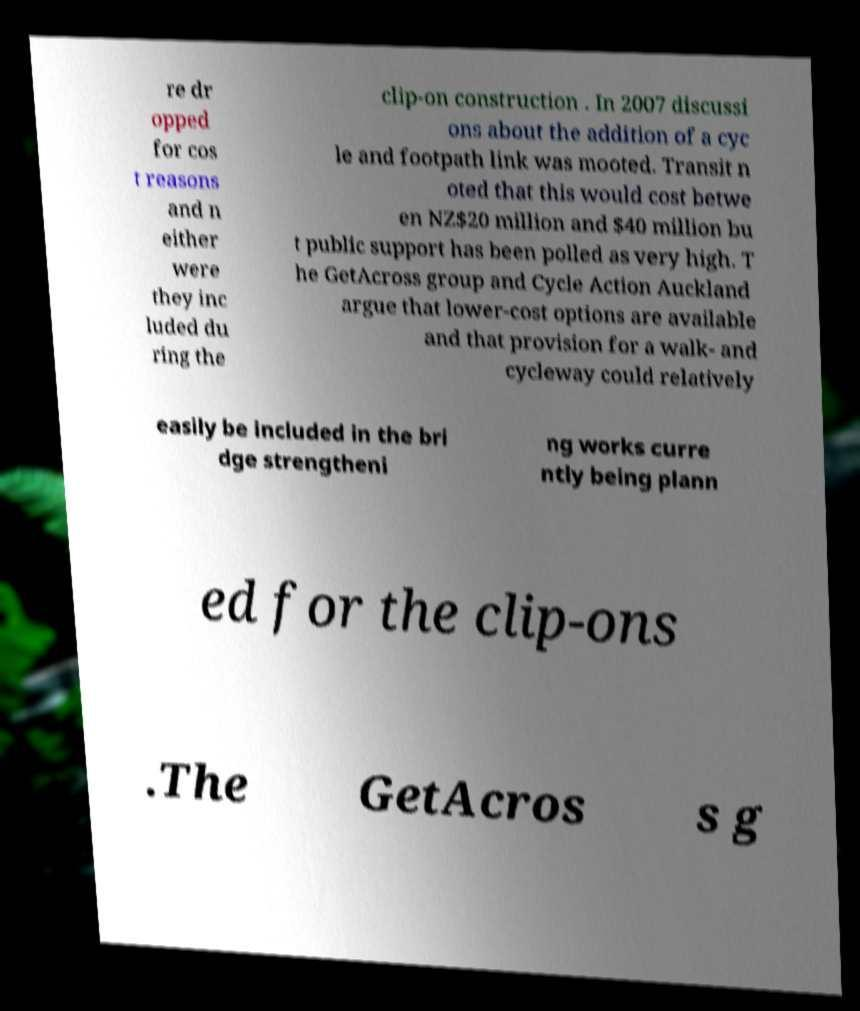Please read and relay the text visible in this image. What does it say? re dr opped for cos t reasons and n either were they inc luded du ring the clip-on construction . In 2007 discussi ons about the addition of a cyc le and footpath link was mooted. Transit n oted that this would cost betwe en NZ$20 million and $40 million bu t public support has been polled as very high. T he GetAcross group and Cycle Action Auckland argue that lower-cost options are available and that provision for a walk- and cycleway could relatively easily be included in the bri dge strengtheni ng works curre ntly being plann ed for the clip-ons .The GetAcros s g 